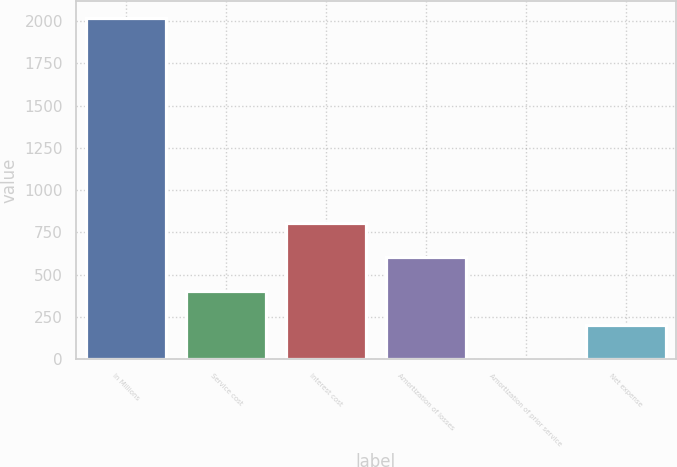Convert chart. <chart><loc_0><loc_0><loc_500><loc_500><bar_chart><fcel>In Millions<fcel>Service cost<fcel>Interest cost<fcel>Amortization of losses<fcel>Amortization of prior service<fcel>Net expense<nl><fcel>2018<fcel>405.12<fcel>808.34<fcel>606.73<fcel>1.9<fcel>203.51<nl></chart> 